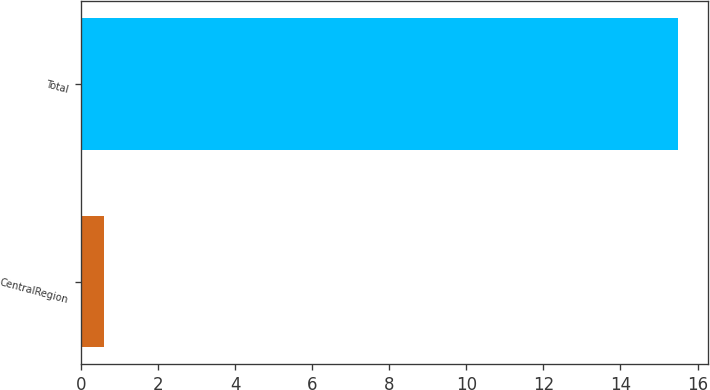<chart> <loc_0><loc_0><loc_500><loc_500><bar_chart><fcel>CentralRegion<fcel>Total<nl><fcel>0.6<fcel>15.5<nl></chart> 